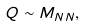Convert formula to latex. <formula><loc_0><loc_0><loc_500><loc_500>Q \sim M _ { N N } ,</formula> 